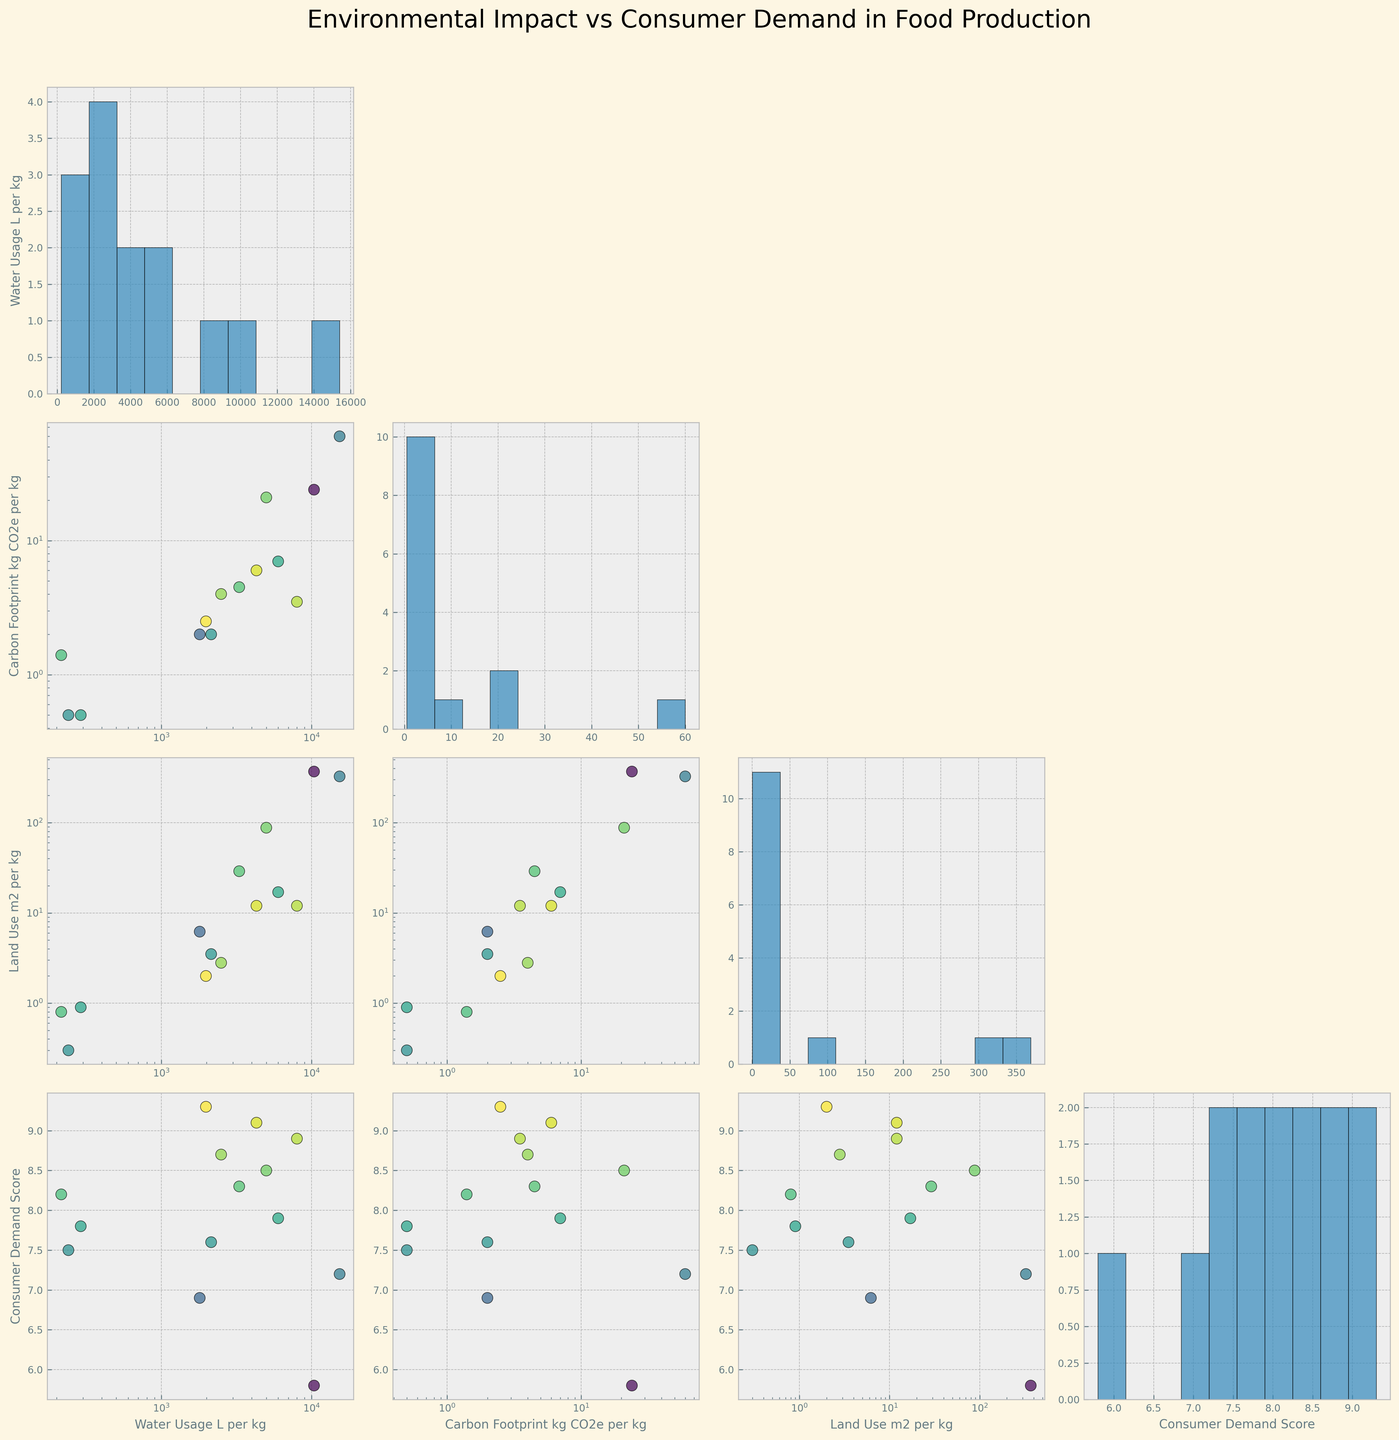What's the title of the plot? The title of the plot is usually found at the top of the figure, giving an overview of what the plot represents. In this case, it is "Environmental Impact vs Consumer Demand in Food Production."
Answer: Environmental Impact vs Consumer Demand in Food Production How many different variables are compared in the scatterplot matrix? The scatterplot matrix compares several variables, evident from the number of different plots along the row and column. Here, four variables are plotted against each other.
Answer: Four Which food type has the highest Consumer Demand Score? By looking at the Consumer Demand Score column in the scatterplot matrix or checking the annotated points, we see that Avocado has the highest Consumer Demand Score at 9.3.
Answer: Avocado Is there a general trend between Water Usage and Consumer Demand Score? By examining the scatterplot for Water Usage (L per kg) on the y-axis and Consumer Demand Score on the x-axis, we can observe if there is a visible trend line. The foods with lower water usage generally have higher Consumer Demand Scores, indicating a negative correlation.
Answer: Negative correlation How does the Carbon Footprint compare between Cheese and Chicken? Checking the points corresponding to Cheese and Chicken in the scatterplot with Carbon Footprint (kg CO2e per kg) on the y-axis, we see Cheese has a footprint of 21 kg CO2e per kg, while Chicken has 6 kg CO2e per kg. Therefore, Cheese has a higher Carbon Footprint.
Answer: Cheese > Chicken Which food type requires the most land use per kg? The food type with the highest value in the Land Use (m² per kg) category needs to be identified. Lamb requires 369 m² per kg, the highest among all the food types.
Answer: Lamb What is the consumer demand score for rice? We find the rice data point in the scatterplot or the legend and note its corresponding Consumer Demand Score, which is 8.7.
Answer: 8.7 Do foods with high Carbon Footprint also have high Water Usage? We examine the scatterplot with Carbon Footprint on one axis and Water Usage on the other axis. Foods with high carbon footprints such as Beef, Lamb, and Cheese tend to also have high water usage, indicating a positive correlation.
Answer: Positive correlation Which food type uses more water per kg: Pork or Tofu? We look at the scatterplots and find the points for Pork and Tofu. Pork uses 6000 L per kg, while Tofu uses 2145 L per kg, so Pork uses more water per kg than Tofu.
Answer: Pork What is the range of Carbon Footprint for the foods plotted? By examining the scatterplots or the histogram for Carbon Footprint, we find that it ranges from 0.5 (Potatoes and Lettuce) to 60 (Beef) kg CO2e per kg.
Answer: 0.5 to 60 kg CO2e per kg 